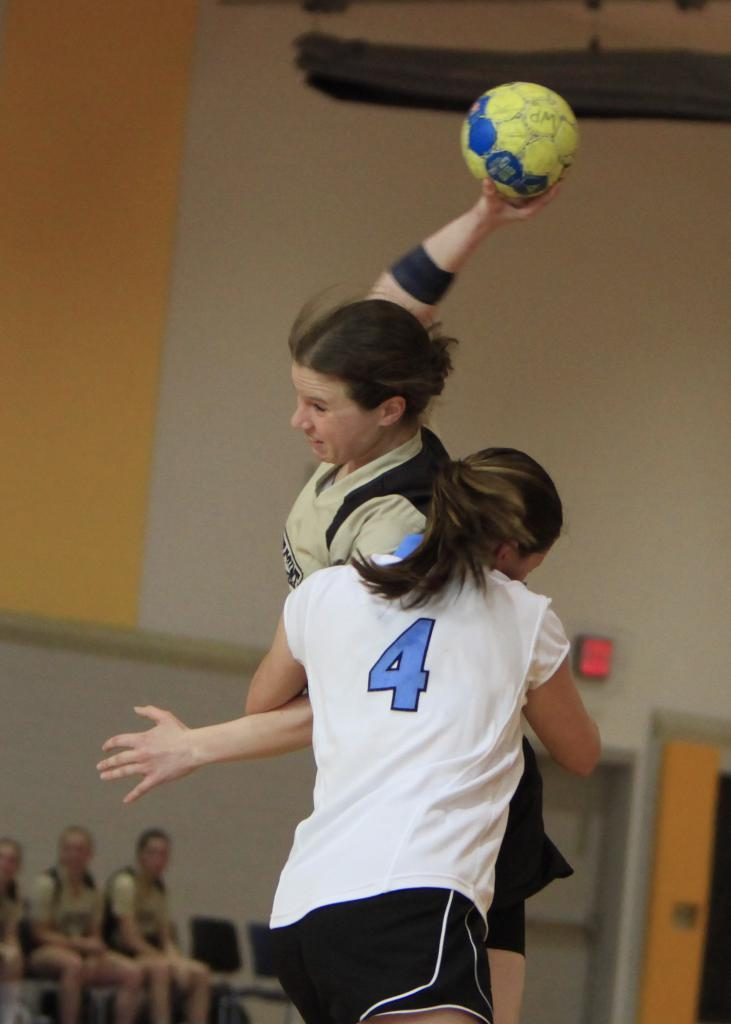<image>
Summarize the visual content of the image. A game being played between female teams with number 4 attacking the opposing team to prevent scoring. 